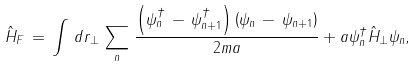Convert formula to latex. <formula><loc_0><loc_0><loc_500><loc_500>\hat { H } _ { F } \, = \, \int \, d { r } _ { \perp } \, \sum _ { n } \, \frac { \left ( \psi ^ { \dagger } _ { n } \, - \, \psi ^ { \dagger } _ { n + 1 } \right ) \left ( \psi _ { n } \, - \, \psi _ { n + 1 } \right ) } { 2 m a } + a \psi ^ { \dagger } _ { n } \hat { H } _ { \perp } \psi _ { n } ,</formula> 